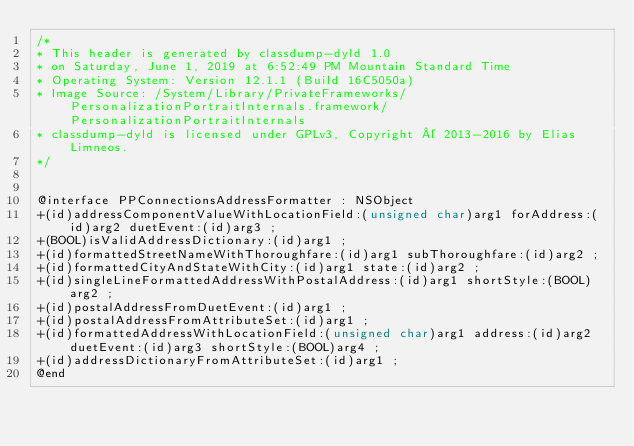<code> <loc_0><loc_0><loc_500><loc_500><_C_>/*
* This header is generated by classdump-dyld 1.0
* on Saturday, June 1, 2019 at 6:52:49 PM Mountain Standard Time
* Operating System: Version 12.1.1 (Build 16C5050a)
* Image Source: /System/Library/PrivateFrameworks/PersonalizationPortraitInternals.framework/PersonalizationPortraitInternals
* classdump-dyld is licensed under GPLv3, Copyright © 2013-2016 by Elias Limneos.
*/


@interface PPConnectionsAddressFormatter : NSObject
+(id)addressComponentValueWithLocationField:(unsigned char)arg1 forAddress:(id)arg2 duetEvent:(id)arg3 ;
+(BOOL)isValidAddressDictionary:(id)arg1 ;
+(id)formattedStreetNameWithThoroughfare:(id)arg1 subThoroughfare:(id)arg2 ;
+(id)formattedCityAndStateWithCity:(id)arg1 state:(id)arg2 ;
+(id)singleLineFormattedAddressWithPostalAddress:(id)arg1 shortStyle:(BOOL)arg2 ;
+(id)postalAddressFromDuetEvent:(id)arg1 ;
+(id)postalAddressFromAttributeSet:(id)arg1 ;
+(id)formattedAddressWithLocationField:(unsigned char)arg1 address:(id)arg2 duetEvent:(id)arg3 shortStyle:(BOOL)arg4 ;
+(id)addressDictionaryFromAttributeSet:(id)arg1 ;
@end

</code> 